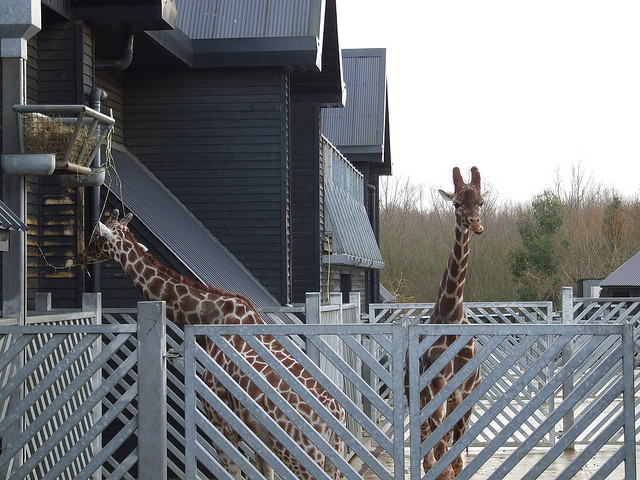<image>What is the giraffe looking at? I don't know what the giraffe is looking at. It could be looking at the camera, the house, the photographer, the window, people, or food. What type of animal is on the fence? I'm not sure what type of animal is on the fence, but it could be a giraffe. What is the giraffe looking at? I don't know what the giraffe is looking at. It can be the camera, house, photographer, or window. What type of animal is on the fence? It is not clear what type of animal is on the fence. It can be seen as a giraffe, but it is difficult to say for sure. 